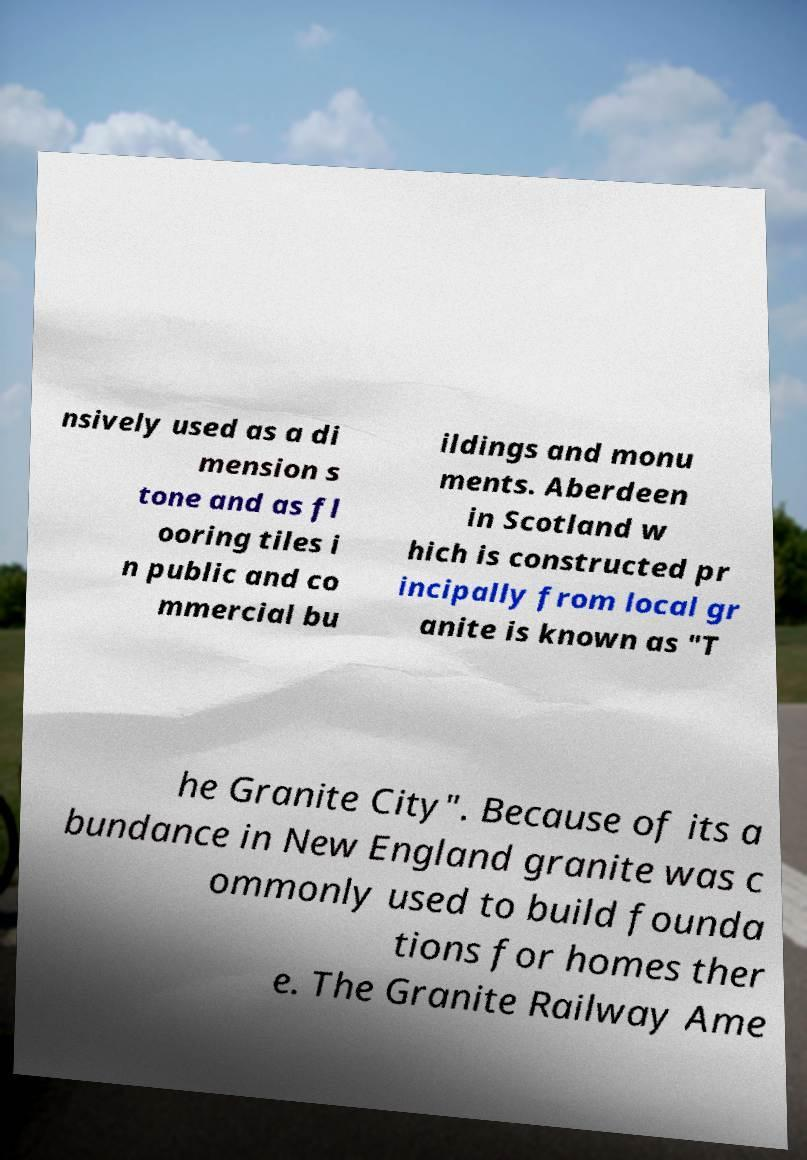I need the written content from this picture converted into text. Can you do that? nsively used as a di mension s tone and as fl ooring tiles i n public and co mmercial bu ildings and monu ments. Aberdeen in Scotland w hich is constructed pr incipally from local gr anite is known as "T he Granite City". Because of its a bundance in New England granite was c ommonly used to build founda tions for homes ther e. The Granite Railway Ame 